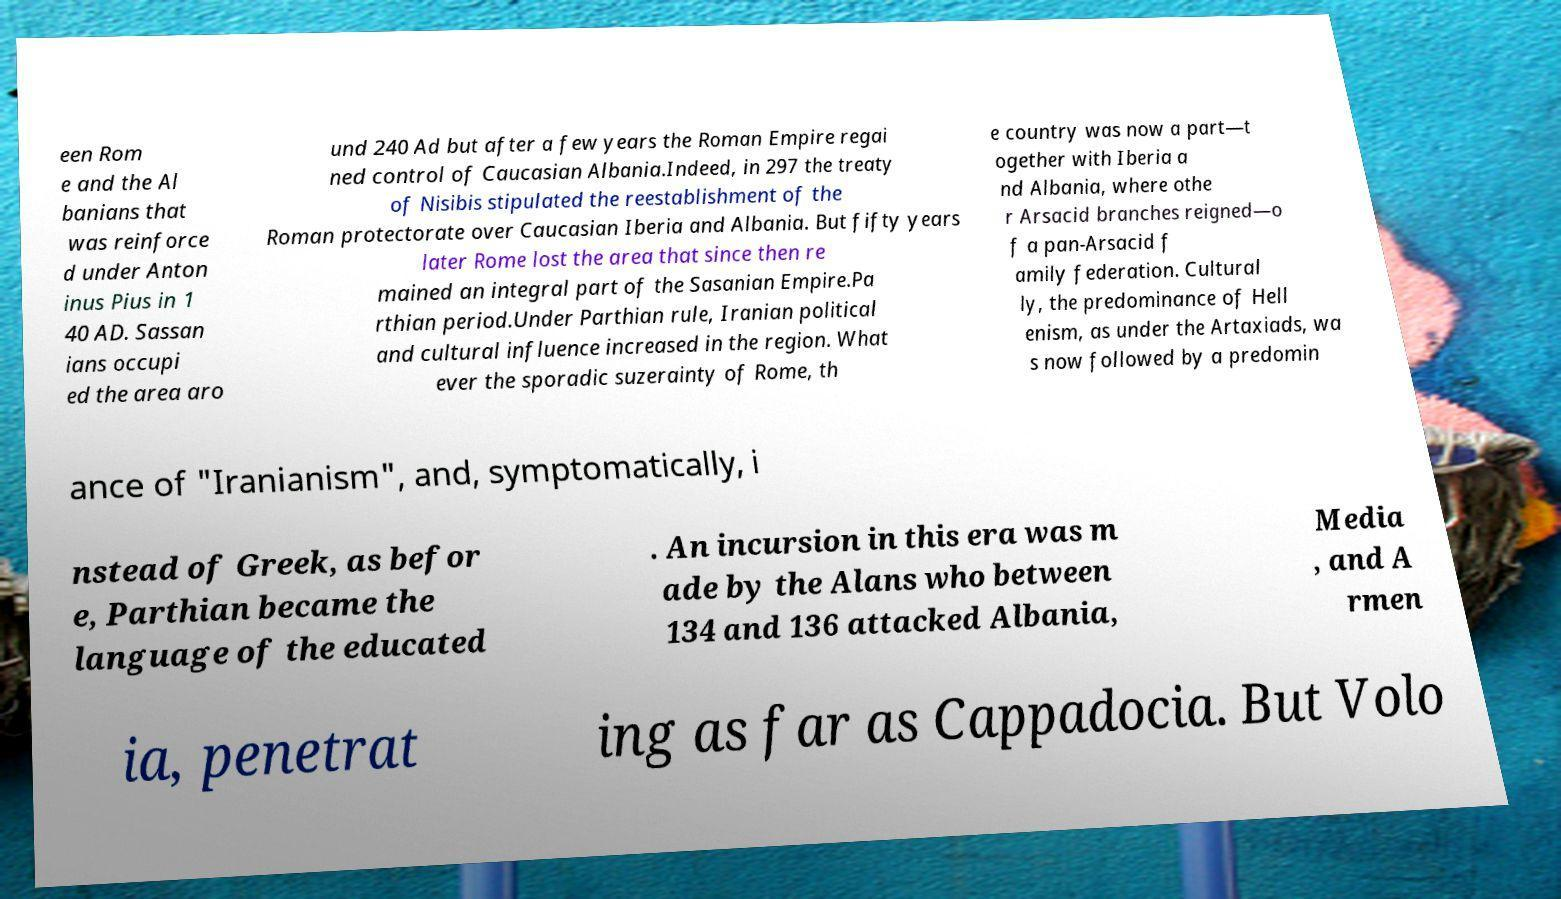Please read and relay the text visible in this image. What does it say? een Rom e and the Al banians that was reinforce d under Anton inus Pius in 1 40 AD. Sassan ians occupi ed the area aro und 240 Ad but after a few years the Roman Empire regai ned control of Caucasian Albania.Indeed, in 297 the treaty of Nisibis stipulated the reestablishment of the Roman protectorate over Caucasian Iberia and Albania. But fifty years later Rome lost the area that since then re mained an integral part of the Sasanian Empire.Pa rthian period.Under Parthian rule, Iranian political and cultural influence increased in the region. What ever the sporadic suzerainty of Rome, th e country was now a part—t ogether with Iberia a nd Albania, where othe r Arsacid branches reigned—o f a pan-Arsacid f amily federation. Cultural ly, the predominance of Hell enism, as under the Artaxiads, wa s now followed by a predomin ance of "Iranianism", and, symptomatically, i nstead of Greek, as befor e, Parthian became the language of the educated . An incursion in this era was m ade by the Alans who between 134 and 136 attacked Albania, Media , and A rmen ia, penetrat ing as far as Cappadocia. But Volo 